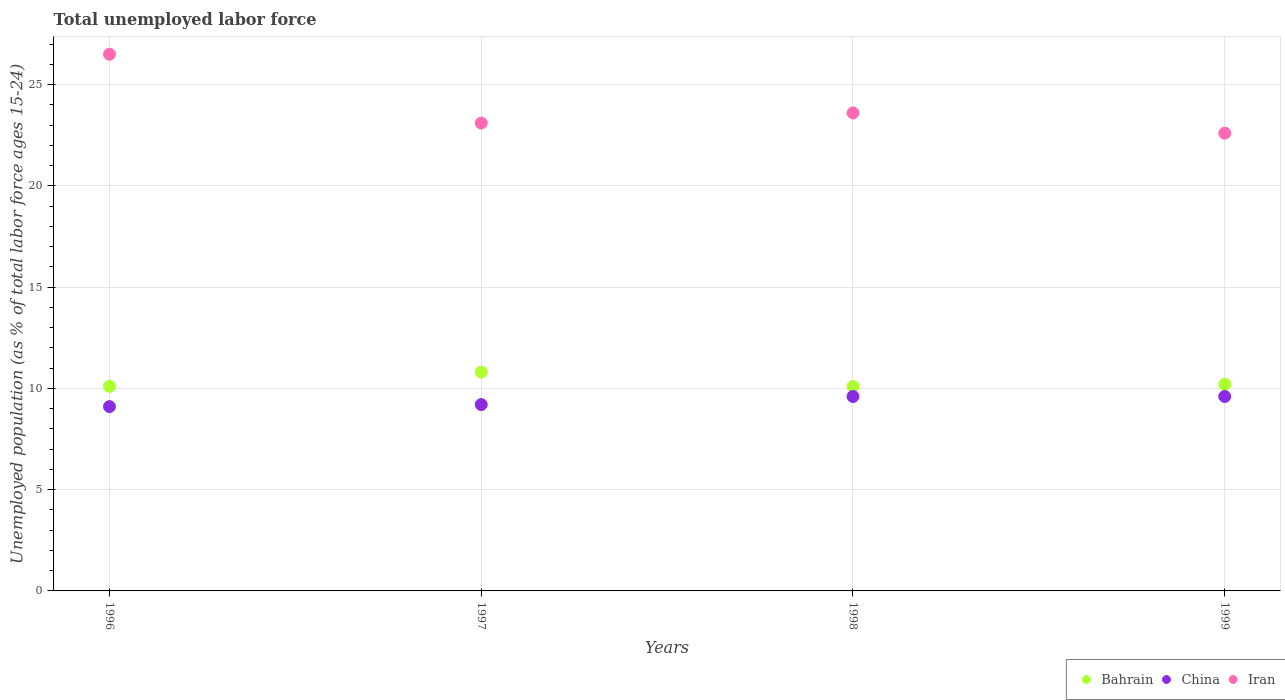How many different coloured dotlines are there?
Give a very brief answer. 3. What is the percentage of unemployed population in in China in 1996?
Your answer should be compact. 9.1. Across all years, what is the maximum percentage of unemployed population in in Iran?
Give a very brief answer. 26.5. Across all years, what is the minimum percentage of unemployed population in in China?
Provide a short and direct response. 9.1. In which year was the percentage of unemployed population in in Iran maximum?
Your answer should be very brief. 1996. What is the total percentage of unemployed population in in Iran in the graph?
Give a very brief answer. 95.8. What is the difference between the percentage of unemployed population in in Bahrain in 1998 and that in 1999?
Make the answer very short. -0.1. What is the difference between the percentage of unemployed population in in Bahrain in 1998 and the percentage of unemployed population in in China in 1999?
Provide a succinct answer. 0.5. What is the average percentage of unemployed population in in China per year?
Offer a very short reply. 9.38. In the year 1998, what is the difference between the percentage of unemployed population in in Iran and percentage of unemployed population in in Bahrain?
Ensure brevity in your answer.  13.5. In how many years, is the percentage of unemployed population in in China greater than 2 %?
Your answer should be very brief. 4. What is the ratio of the percentage of unemployed population in in China in 1997 to that in 1998?
Your response must be concise. 0.96. Is the percentage of unemployed population in in Bahrain in 1996 less than that in 1999?
Your answer should be compact. Yes. What is the difference between the highest and the second highest percentage of unemployed population in in China?
Offer a terse response. 0. What is the difference between the highest and the lowest percentage of unemployed population in in China?
Give a very brief answer. 0.5. Is it the case that in every year, the sum of the percentage of unemployed population in in Iran and percentage of unemployed population in in Bahrain  is greater than the percentage of unemployed population in in China?
Your response must be concise. Yes. Does the percentage of unemployed population in in China monotonically increase over the years?
Your answer should be compact. No. Is the percentage of unemployed population in in China strictly greater than the percentage of unemployed population in in Bahrain over the years?
Make the answer very short. No. How many dotlines are there?
Offer a very short reply. 3. Are the values on the major ticks of Y-axis written in scientific E-notation?
Your response must be concise. No. Does the graph contain any zero values?
Give a very brief answer. No. Where does the legend appear in the graph?
Make the answer very short. Bottom right. How are the legend labels stacked?
Your answer should be very brief. Horizontal. What is the title of the graph?
Your answer should be very brief. Total unemployed labor force. What is the label or title of the Y-axis?
Ensure brevity in your answer.  Unemployed population (as % of total labor force ages 15-24). What is the Unemployed population (as % of total labor force ages 15-24) in Bahrain in 1996?
Your answer should be compact. 10.1. What is the Unemployed population (as % of total labor force ages 15-24) of China in 1996?
Offer a terse response. 9.1. What is the Unemployed population (as % of total labor force ages 15-24) of Bahrain in 1997?
Your answer should be compact. 10.8. What is the Unemployed population (as % of total labor force ages 15-24) in China in 1997?
Offer a terse response. 9.2. What is the Unemployed population (as % of total labor force ages 15-24) of Iran in 1997?
Offer a very short reply. 23.1. What is the Unemployed population (as % of total labor force ages 15-24) of Bahrain in 1998?
Provide a succinct answer. 10.1. What is the Unemployed population (as % of total labor force ages 15-24) of China in 1998?
Provide a short and direct response. 9.6. What is the Unemployed population (as % of total labor force ages 15-24) of Iran in 1998?
Offer a terse response. 23.6. What is the Unemployed population (as % of total labor force ages 15-24) of Bahrain in 1999?
Your response must be concise. 10.2. What is the Unemployed population (as % of total labor force ages 15-24) in China in 1999?
Make the answer very short. 9.6. What is the Unemployed population (as % of total labor force ages 15-24) of Iran in 1999?
Provide a succinct answer. 22.6. Across all years, what is the maximum Unemployed population (as % of total labor force ages 15-24) in Bahrain?
Offer a very short reply. 10.8. Across all years, what is the maximum Unemployed population (as % of total labor force ages 15-24) in China?
Provide a succinct answer. 9.6. Across all years, what is the minimum Unemployed population (as % of total labor force ages 15-24) of Bahrain?
Your answer should be compact. 10.1. Across all years, what is the minimum Unemployed population (as % of total labor force ages 15-24) in China?
Offer a terse response. 9.1. Across all years, what is the minimum Unemployed population (as % of total labor force ages 15-24) in Iran?
Provide a short and direct response. 22.6. What is the total Unemployed population (as % of total labor force ages 15-24) in Bahrain in the graph?
Offer a terse response. 41.2. What is the total Unemployed population (as % of total labor force ages 15-24) of China in the graph?
Offer a terse response. 37.5. What is the total Unemployed population (as % of total labor force ages 15-24) of Iran in the graph?
Give a very brief answer. 95.8. What is the difference between the Unemployed population (as % of total labor force ages 15-24) of Bahrain in 1996 and that in 1997?
Offer a very short reply. -0.7. What is the difference between the Unemployed population (as % of total labor force ages 15-24) of China in 1996 and that in 1997?
Your response must be concise. -0.1. What is the difference between the Unemployed population (as % of total labor force ages 15-24) of Iran in 1996 and that in 1997?
Ensure brevity in your answer.  3.4. What is the difference between the Unemployed population (as % of total labor force ages 15-24) in Bahrain in 1996 and that in 1998?
Make the answer very short. 0. What is the difference between the Unemployed population (as % of total labor force ages 15-24) in China in 1996 and that in 1998?
Keep it short and to the point. -0.5. What is the difference between the Unemployed population (as % of total labor force ages 15-24) of Iran in 1996 and that in 1998?
Make the answer very short. 2.9. What is the difference between the Unemployed population (as % of total labor force ages 15-24) of Bahrain in 1996 and that in 1999?
Offer a very short reply. -0.1. What is the difference between the Unemployed population (as % of total labor force ages 15-24) in Iran in 1996 and that in 1999?
Your response must be concise. 3.9. What is the difference between the Unemployed population (as % of total labor force ages 15-24) in China in 1997 and that in 1998?
Your response must be concise. -0.4. What is the difference between the Unemployed population (as % of total labor force ages 15-24) of Iran in 1997 and that in 1998?
Provide a short and direct response. -0.5. What is the difference between the Unemployed population (as % of total labor force ages 15-24) in China in 1998 and that in 1999?
Keep it short and to the point. 0. What is the difference between the Unemployed population (as % of total labor force ages 15-24) of Iran in 1998 and that in 1999?
Your response must be concise. 1. What is the difference between the Unemployed population (as % of total labor force ages 15-24) in China in 1996 and the Unemployed population (as % of total labor force ages 15-24) in Iran in 1997?
Keep it short and to the point. -14. What is the difference between the Unemployed population (as % of total labor force ages 15-24) in Bahrain in 1996 and the Unemployed population (as % of total labor force ages 15-24) in China in 1998?
Provide a succinct answer. 0.5. What is the difference between the Unemployed population (as % of total labor force ages 15-24) in China in 1996 and the Unemployed population (as % of total labor force ages 15-24) in Iran in 1998?
Your answer should be compact. -14.5. What is the difference between the Unemployed population (as % of total labor force ages 15-24) in Bahrain in 1996 and the Unemployed population (as % of total labor force ages 15-24) in Iran in 1999?
Offer a very short reply. -12.5. What is the difference between the Unemployed population (as % of total labor force ages 15-24) in China in 1996 and the Unemployed population (as % of total labor force ages 15-24) in Iran in 1999?
Offer a terse response. -13.5. What is the difference between the Unemployed population (as % of total labor force ages 15-24) in China in 1997 and the Unemployed population (as % of total labor force ages 15-24) in Iran in 1998?
Ensure brevity in your answer.  -14.4. What is the difference between the Unemployed population (as % of total labor force ages 15-24) in China in 1997 and the Unemployed population (as % of total labor force ages 15-24) in Iran in 1999?
Make the answer very short. -13.4. What is the difference between the Unemployed population (as % of total labor force ages 15-24) in Bahrain in 1998 and the Unemployed population (as % of total labor force ages 15-24) in Iran in 1999?
Your answer should be very brief. -12.5. What is the difference between the Unemployed population (as % of total labor force ages 15-24) in China in 1998 and the Unemployed population (as % of total labor force ages 15-24) in Iran in 1999?
Ensure brevity in your answer.  -13. What is the average Unemployed population (as % of total labor force ages 15-24) in China per year?
Provide a succinct answer. 9.38. What is the average Unemployed population (as % of total labor force ages 15-24) in Iran per year?
Provide a short and direct response. 23.95. In the year 1996, what is the difference between the Unemployed population (as % of total labor force ages 15-24) of Bahrain and Unemployed population (as % of total labor force ages 15-24) of Iran?
Provide a succinct answer. -16.4. In the year 1996, what is the difference between the Unemployed population (as % of total labor force ages 15-24) in China and Unemployed population (as % of total labor force ages 15-24) in Iran?
Provide a short and direct response. -17.4. In the year 1997, what is the difference between the Unemployed population (as % of total labor force ages 15-24) of Bahrain and Unemployed population (as % of total labor force ages 15-24) of Iran?
Offer a very short reply. -12.3. In the year 1998, what is the difference between the Unemployed population (as % of total labor force ages 15-24) in Bahrain and Unemployed population (as % of total labor force ages 15-24) in Iran?
Provide a succinct answer. -13.5. In the year 1999, what is the difference between the Unemployed population (as % of total labor force ages 15-24) of China and Unemployed population (as % of total labor force ages 15-24) of Iran?
Your response must be concise. -13. What is the ratio of the Unemployed population (as % of total labor force ages 15-24) of Bahrain in 1996 to that in 1997?
Provide a succinct answer. 0.94. What is the ratio of the Unemployed population (as % of total labor force ages 15-24) in Iran in 1996 to that in 1997?
Ensure brevity in your answer.  1.15. What is the ratio of the Unemployed population (as % of total labor force ages 15-24) in Bahrain in 1996 to that in 1998?
Your response must be concise. 1. What is the ratio of the Unemployed population (as % of total labor force ages 15-24) in China in 1996 to that in 1998?
Your answer should be compact. 0.95. What is the ratio of the Unemployed population (as % of total labor force ages 15-24) in Iran in 1996 to that in 1998?
Your answer should be very brief. 1.12. What is the ratio of the Unemployed population (as % of total labor force ages 15-24) in Bahrain in 1996 to that in 1999?
Your answer should be very brief. 0.99. What is the ratio of the Unemployed population (as % of total labor force ages 15-24) of China in 1996 to that in 1999?
Ensure brevity in your answer.  0.95. What is the ratio of the Unemployed population (as % of total labor force ages 15-24) in Iran in 1996 to that in 1999?
Keep it short and to the point. 1.17. What is the ratio of the Unemployed population (as % of total labor force ages 15-24) in Bahrain in 1997 to that in 1998?
Make the answer very short. 1.07. What is the ratio of the Unemployed population (as % of total labor force ages 15-24) in China in 1997 to that in 1998?
Ensure brevity in your answer.  0.96. What is the ratio of the Unemployed population (as % of total labor force ages 15-24) in Iran in 1997 to that in 1998?
Offer a terse response. 0.98. What is the ratio of the Unemployed population (as % of total labor force ages 15-24) in Bahrain in 1997 to that in 1999?
Offer a very short reply. 1.06. What is the ratio of the Unemployed population (as % of total labor force ages 15-24) in Iran in 1997 to that in 1999?
Offer a very short reply. 1.02. What is the ratio of the Unemployed population (as % of total labor force ages 15-24) of Bahrain in 1998 to that in 1999?
Offer a terse response. 0.99. What is the ratio of the Unemployed population (as % of total labor force ages 15-24) of China in 1998 to that in 1999?
Make the answer very short. 1. What is the ratio of the Unemployed population (as % of total labor force ages 15-24) in Iran in 1998 to that in 1999?
Your response must be concise. 1.04. What is the difference between the highest and the second highest Unemployed population (as % of total labor force ages 15-24) of China?
Ensure brevity in your answer.  0. What is the difference between the highest and the second highest Unemployed population (as % of total labor force ages 15-24) in Iran?
Give a very brief answer. 2.9. What is the difference between the highest and the lowest Unemployed population (as % of total labor force ages 15-24) of China?
Provide a short and direct response. 0.5. What is the difference between the highest and the lowest Unemployed population (as % of total labor force ages 15-24) in Iran?
Offer a very short reply. 3.9. 